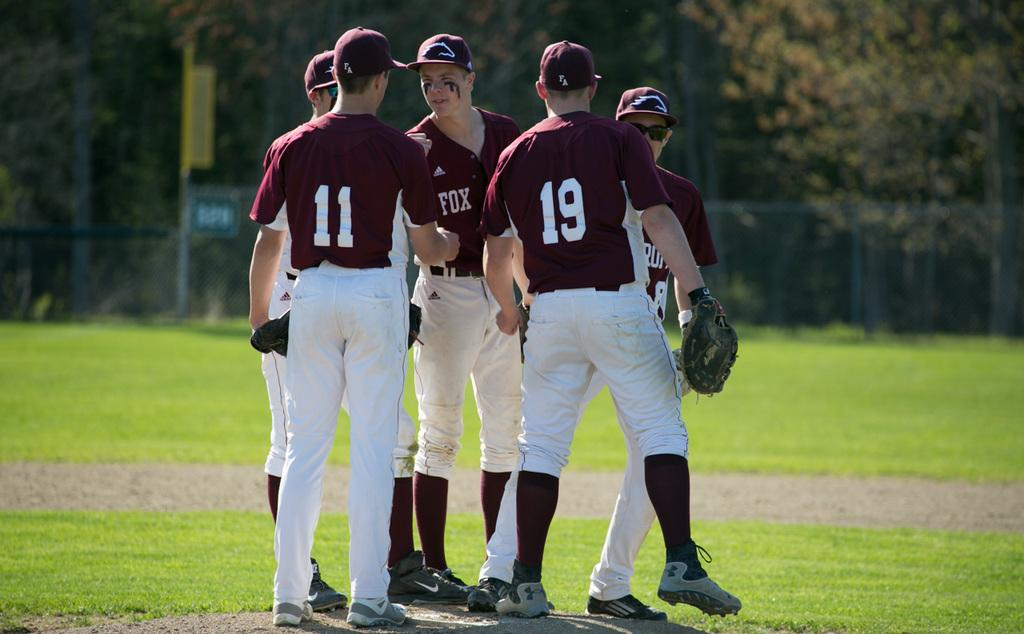<image>
Provide a brief description of the given image. Players number 11 and 19 are in a group with someone named Fox. 